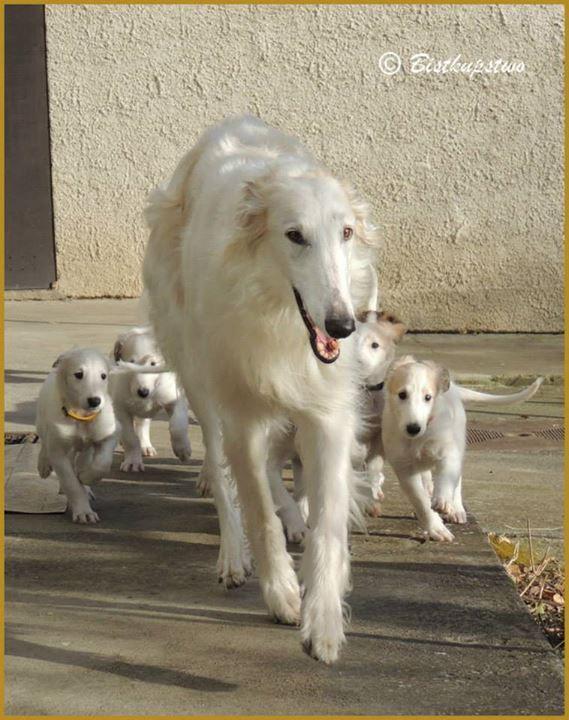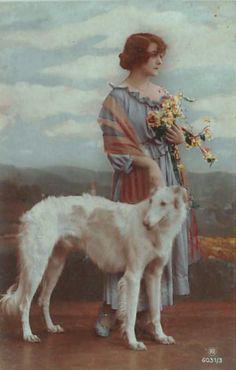The first image is the image on the left, the second image is the image on the right. Analyze the images presented: Is the assertion "A woman is standing with a single dog in the image on the right." valid? Answer yes or no. Yes. The first image is the image on the left, the second image is the image on the right. Examine the images to the left and right. Is the description "The right image shows a woman in a long dress, standing behind an afghan hound, with flowers held in one hand." accurate? Answer yes or no. Yes. 